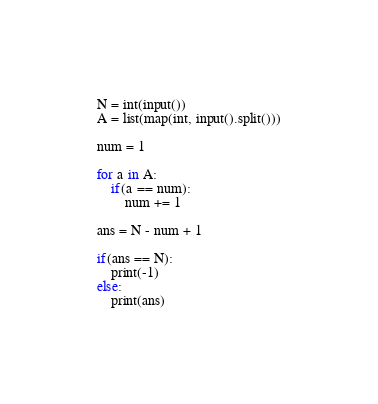<code> <loc_0><loc_0><loc_500><loc_500><_Python_>N = int(input())
A = list(map(int, input().split()))

num = 1

for a in A:
    if(a == num):
        num += 1

ans = N - num + 1

if(ans == N):
    print(-1)
else:
    print(ans)
</code> 